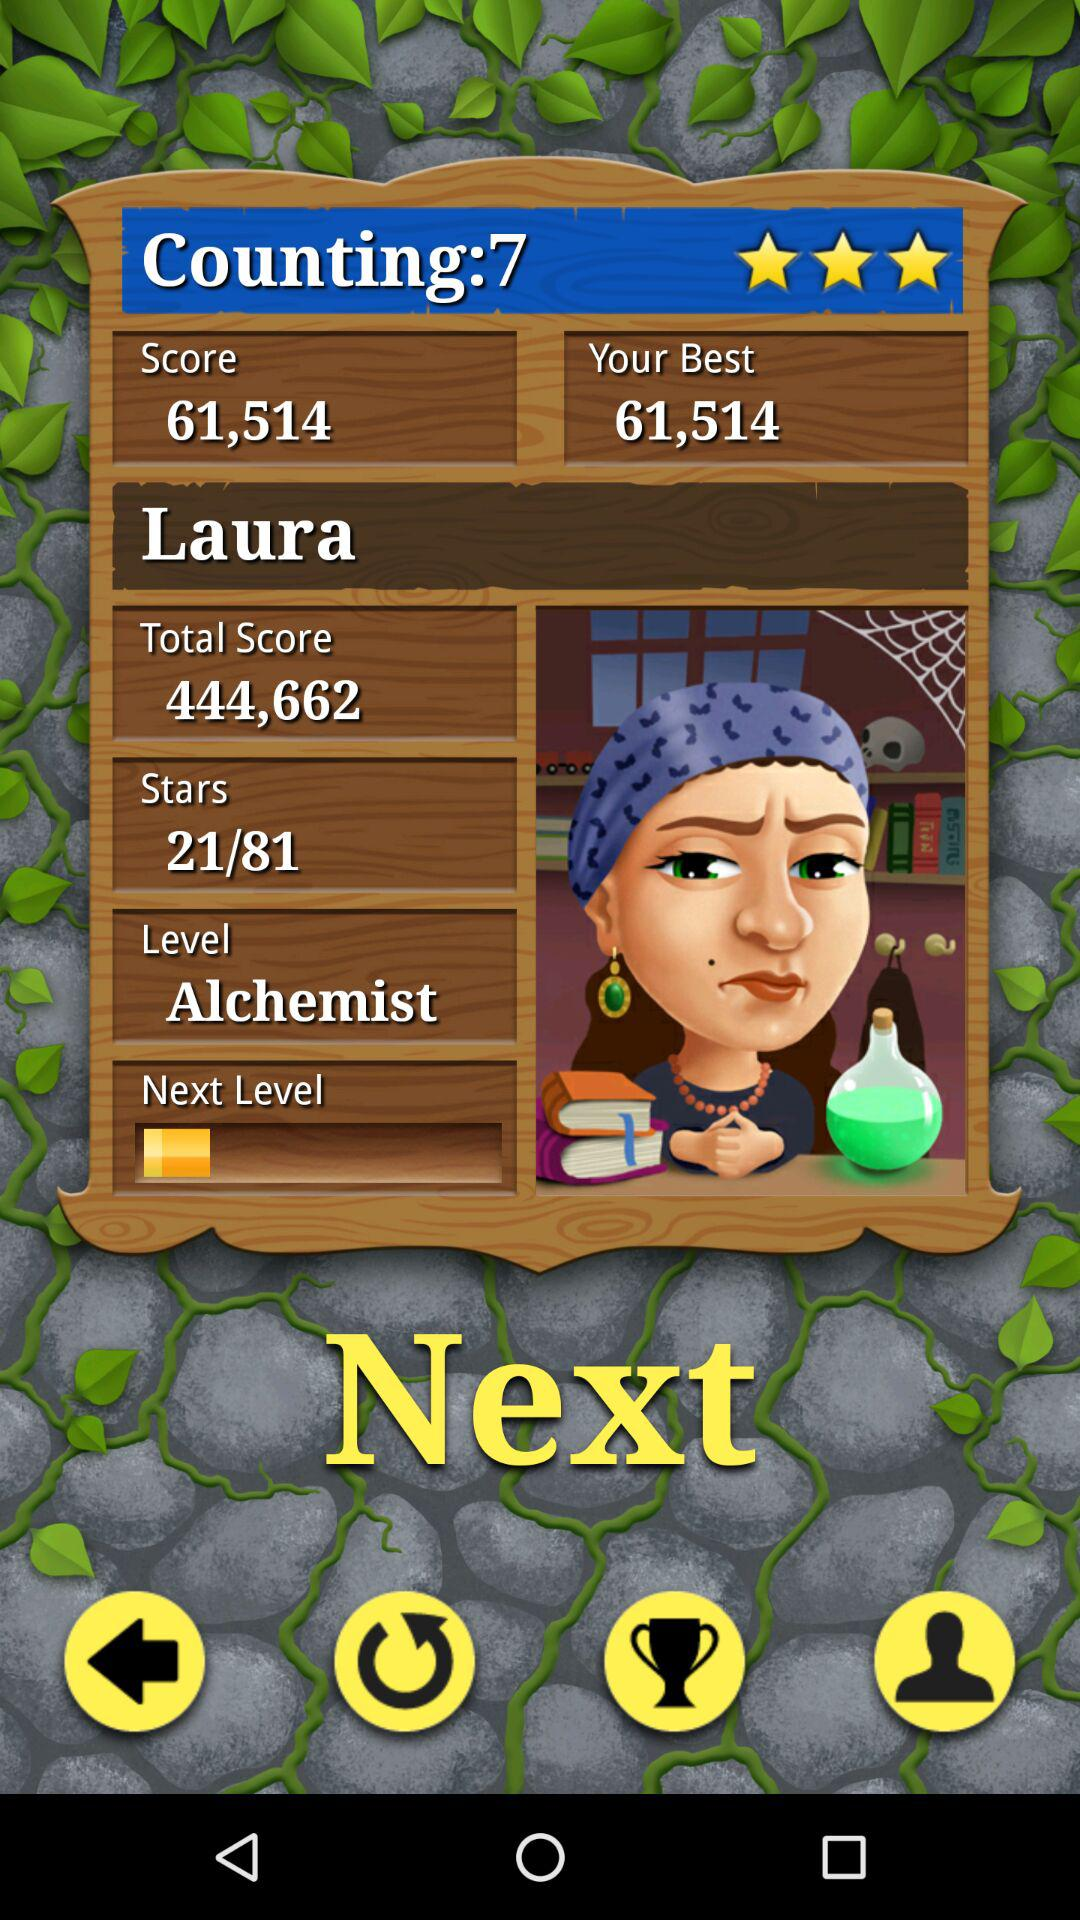What is the total score? The total score is 444,662. 